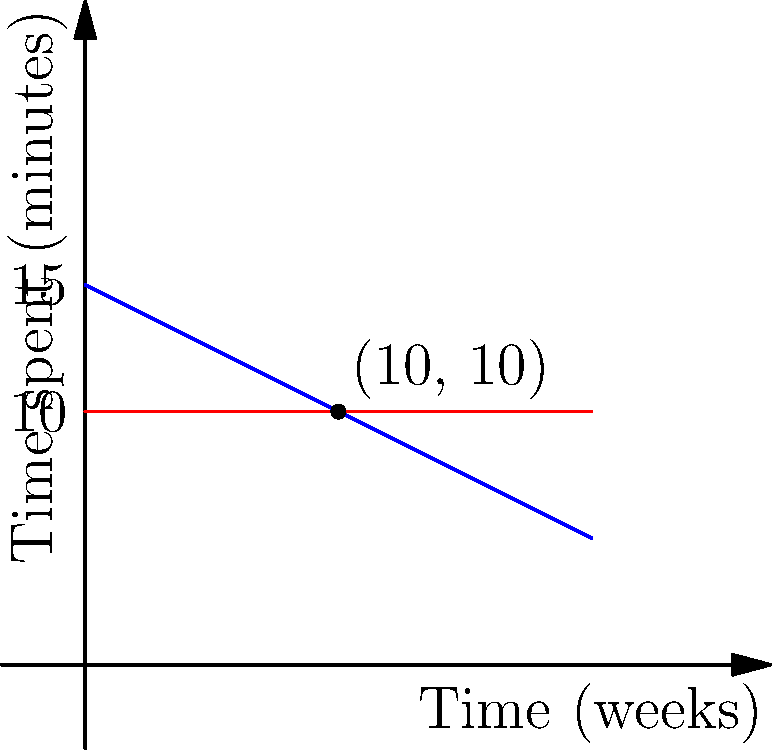The graph shows the time spent on carrying a baby using traditional methods versus a baby sling over a period of 20 weeks. The blue line represents traditional carrying methods, while the red line represents using a baby sling. At how many weeks does the time spent using traditional methods equal the time spent using a baby sling? What is this time in minutes? To solve this problem, we need to find the point where the two lines intersect. This can be done by setting up an equation:

1) The equation for the blue line (traditional carrying) is:
   $y = 15 - 0.5x$, where $y$ is time spent in minutes and $x$ is time in weeks.

2) The equation for the red line (baby sling) is:
   $y = 10$ (constant)

3) At the intersection point, these are equal:
   $15 - 0.5x = 10$

4) Solve for $x$:
   $15 - 10 = 0.5x$
   $5 = 0.5x$
   $x = 10$ weeks

5) To find the time spent at this point, substitute $x = 10$ into either equation:
   $y = 15 - 0.5(10) = 15 - 5 = 10$ minutes

Therefore, the lines intersect at 10 weeks, and at this point, both methods take 10 minutes.
Answer: 10 weeks, 10 minutes 